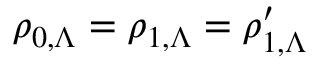<formula> <loc_0><loc_0><loc_500><loc_500>\rho _ { 0 , \Lambda } = \rho _ { 1 , \Lambda } = \rho _ { 1 , \Lambda } ^ { \prime }</formula> 